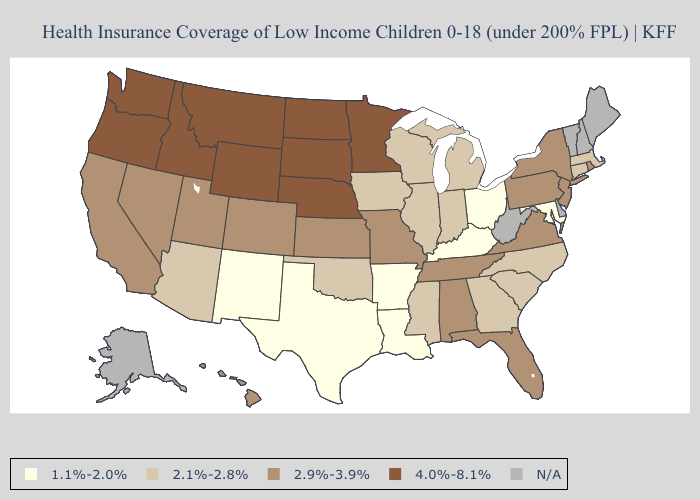Which states have the highest value in the USA?
Answer briefly. Idaho, Minnesota, Montana, Nebraska, North Dakota, Oregon, South Dakota, Washington, Wyoming. Is the legend a continuous bar?
Concise answer only. No. What is the lowest value in states that border Connecticut?
Short answer required. 2.1%-2.8%. Name the states that have a value in the range N/A?
Keep it brief. Alaska, Delaware, Maine, New Hampshire, Vermont, West Virginia. Name the states that have a value in the range 4.0%-8.1%?
Give a very brief answer. Idaho, Minnesota, Montana, Nebraska, North Dakota, Oregon, South Dakota, Washington, Wyoming. What is the highest value in the South ?
Write a very short answer. 2.9%-3.9%. What is the value of Wyoming?
Keep it brief. 4.0%-8.1%. What is the value of New Jersey?
Answer briefly. 2.9%-3.9%. Name the states that have a value in the range N/A?
Be succinct. Alaska, Delaware, Maine, New Hampshire, Vermont, West Virginia. Does Tennessee have the lowest value in the South?
Short answer required. No. What is the value of North Dakota?
Quick response, please. 4.0%-8.1%. What is the value of Pennsylvania?
Short answer required. 2.9%-3.9%. 